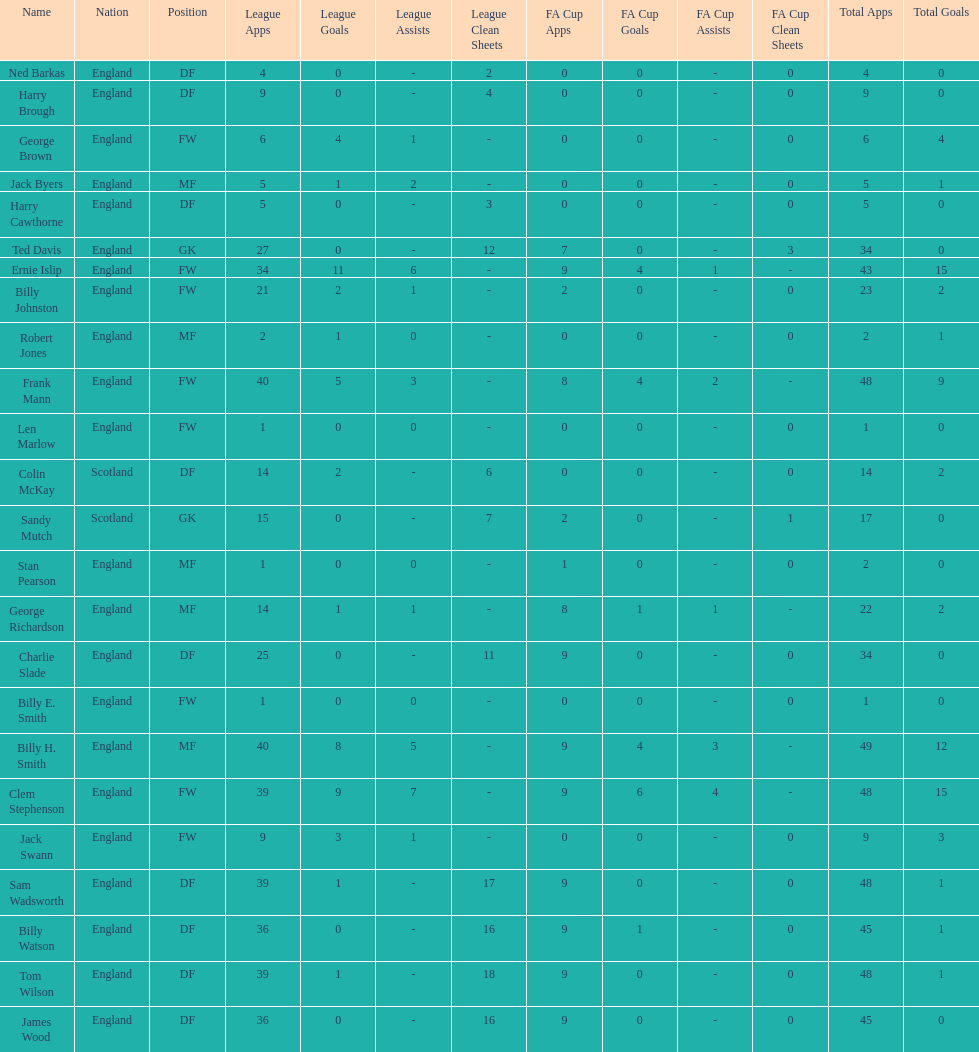Name the nation with the most appearances. England. 